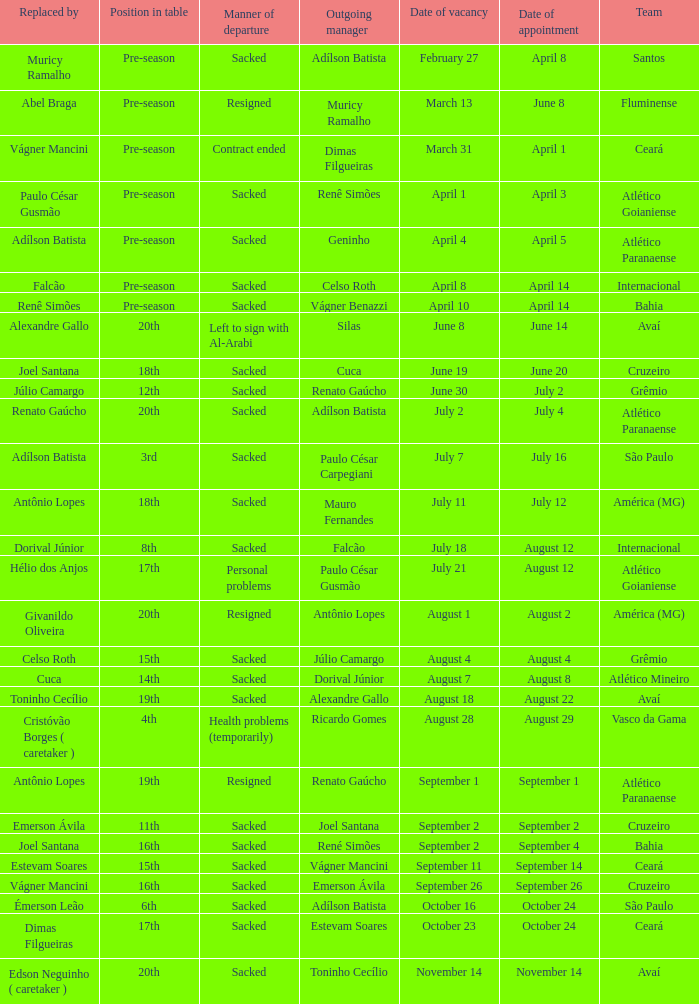Who was replaced as manager on June 20? Cuca. 